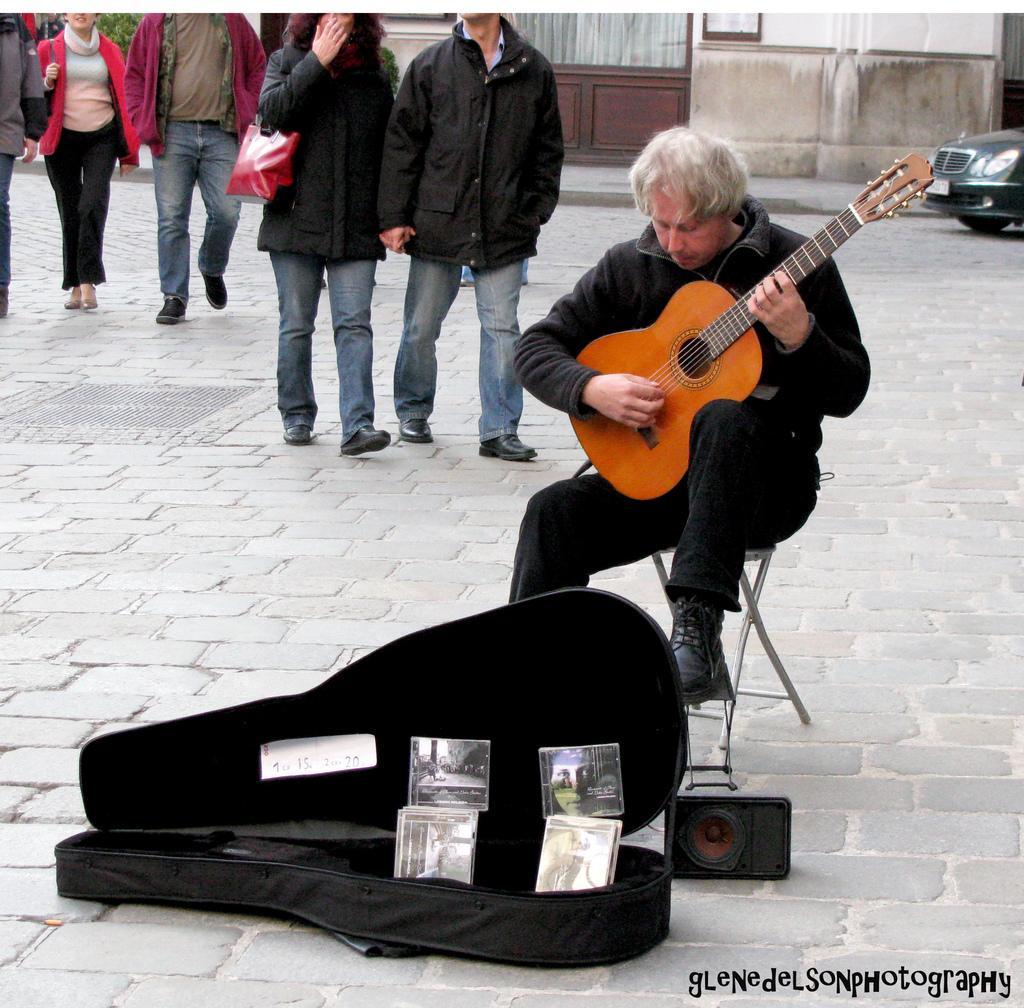How would you summarize this image in a sentence or two? A person is playing guitar in front of him there is a bag and speaker. Behind him there are few people are walking,a building,door and a car. 